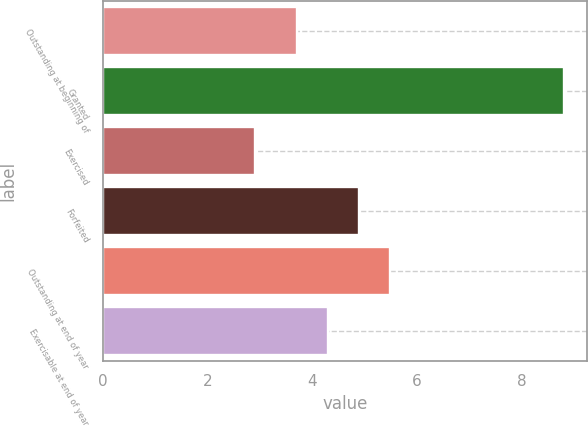<chart> <loc_0><loc_0><loc_500><loc_500><bar_chart><fcel>Outstanding at beginning of<fcel>Granted<fcel>Exercised<fcel>Forfeited<fcel>Outstanding at end of year<fcel>Exercisable at end of year<nl><fcel>3.71<fcel>8.82<fcel>2.9<fcel>4.89<fcel>5.48<fcel>4.3<nl></chart> 